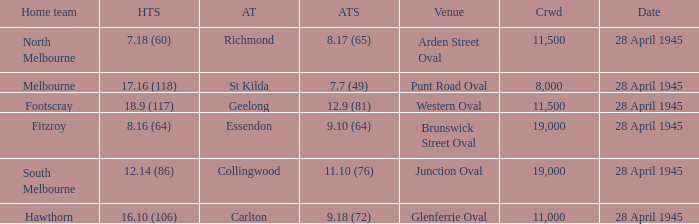What away team played at western oval? Geelong. 